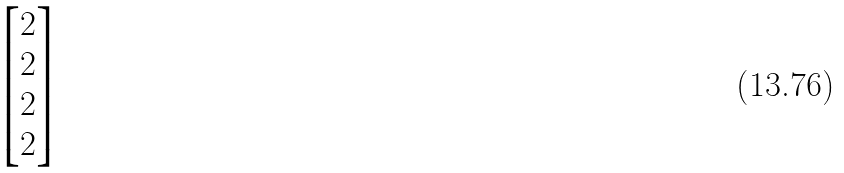Convert formula to latex. <formula><loc_0><loc_0><loc_500><loc_500>\begin{bmatrix} 2 \\ 2 \\ 2 \\ 2 \end{bmatrix}</formula> 